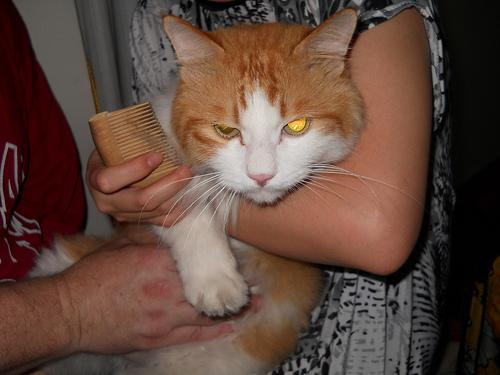Question: where is the light source?
Choices:
A. In front of the cat.
B. Behind the cat.
C. There is no light.
D. Above the cat.
Answer with the letter. Answer: A Question: what age is the cat?
Choices:
A. A baby.
B. There is no cat.
C. Elderly.
D. Full grown adult.
Answer with the letter. Answer: D Question: what causes the eye to glow?
Choices:
A. An LED.
B. The eye is fake, and a light is behind it.
C. A reflection of light.
D. There are lights on the eyelid.
Answer with the letter. Answer: C 